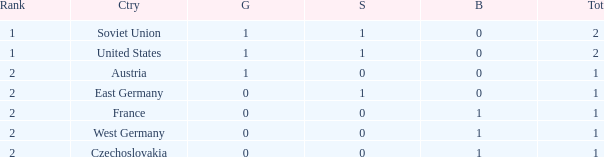What is the total number of bronze medals of West Germany, which is ranked 2 and has less than 1 total medals? 0.0. 